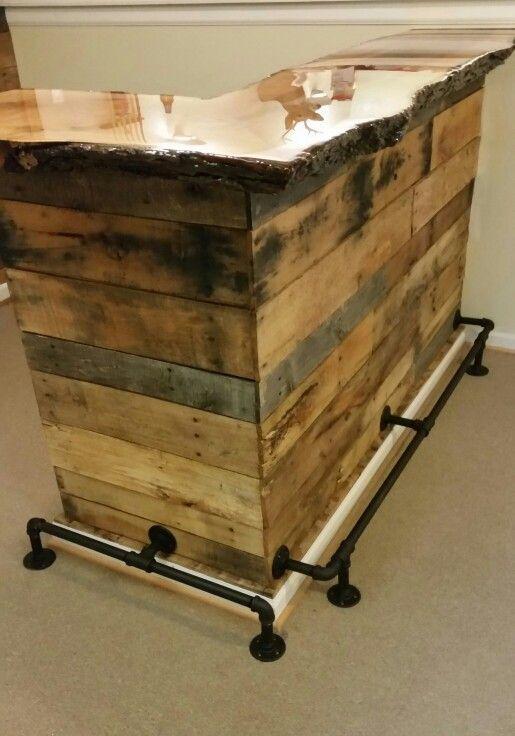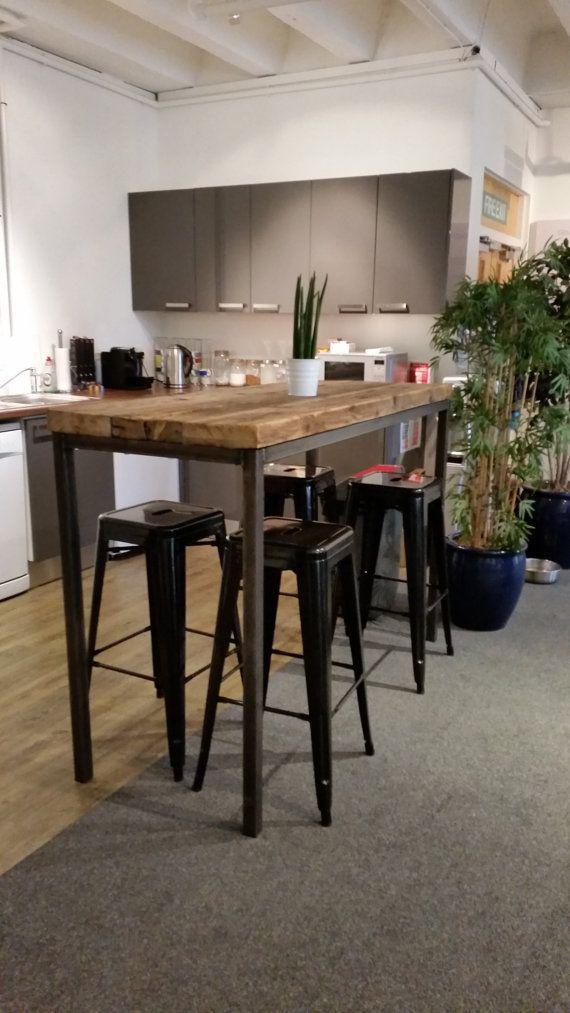The first image is the image on the left, the second image is the image on the right. Considering the images on both sides, is "There is a total of three green barrell with a wooden table top." valid? Answer yes or no. No. The first image is the image on the left, the second image is the image on the right. For the images shown, is this caption "There are three green drums, with a wooden table running across the top of the drums." true? Answer yes or no. No. 